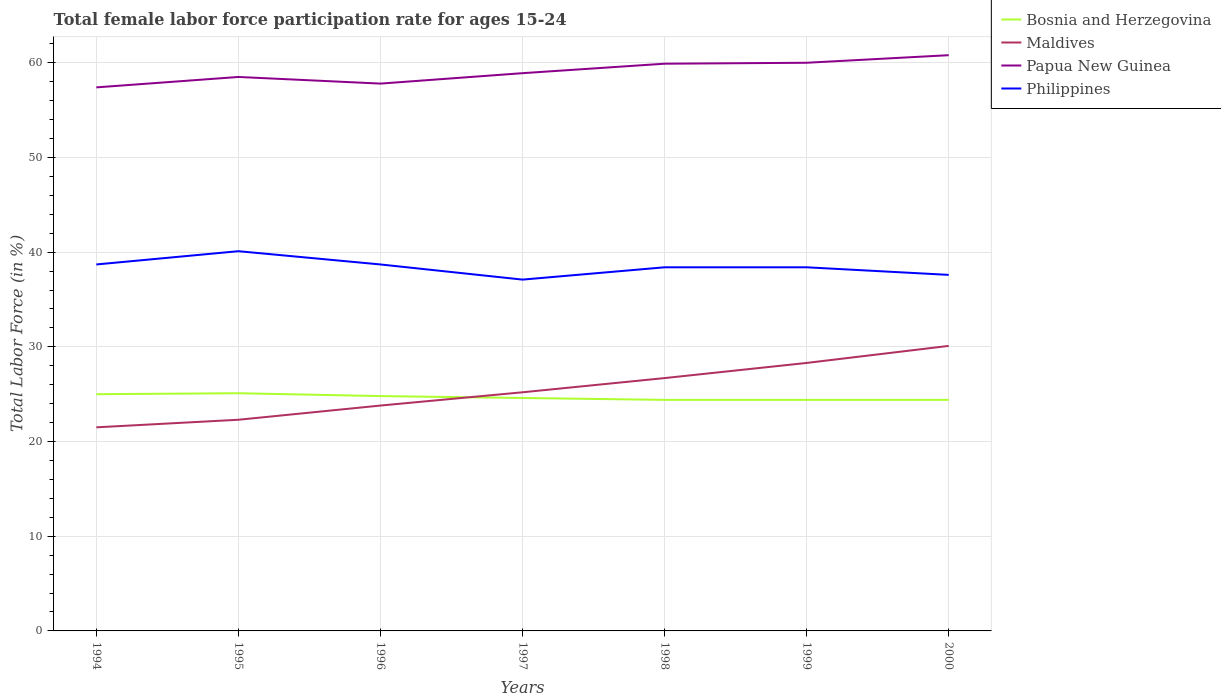Does the line corresponding to Maldives intersect with the line corresponding to Philippines?
Your answer should be very brief. No. Is the number of lines equal to the number of legend labels?
Give a very brief answer. Yes. What is the total female labor force participation rate in Philippines in the graph?
Provide a short and direct response. -1.4. What is the difference between the highest and the second highest female labor force participation rate in Bosnia and Herzegovina?
Offer a terse response. 0.7. What is the difference between the highest and the lowest female labor force participation rate in Philippines?
Provide a short and direct response. 3. Does the graph contain any zero values?
Offer a terse response. No. Where does the legend appear in the graph?
Ensure brevity in your answer.  Top right. How many legend labels are there?
Provide a succinct answer. 4. How are the legend labels stacked?
Your answer should be compact. Vertical. What is the title of the graph?
Your answer should be compact. Total female labor force participation rate for ages 15-24. Does "Costa Rica" appear as one of the legend labels in the graph?
Give a very brief answer. No. What is the Total Labor Force (in %) in Bosnia and Herzegovina in 1994?
Keep it short and to the point. 25. What is the Total Labor Force (in %) of Maldives in 1994?
Your answer should be compact. 21.5. What is the Total Labor Force (in %) of Papua New Guinea in 1994?
Your answer should be very brief. 57.4. What is the Total Labor Force (in %) of Philippines in 1994?
Ensure brevity in your answer.  38.7. What is the Total Labor Force (in %) in Bosnia and Herzegovina in 1995?
Make the answer very short. 25.1. What is the Total Labor Force (in %) of Maldives in 1995?
Your answer should be compact. 22.3. What is the Total Labor Force (in %) in Papua New Guinea in 1995?
Keep it short and to the point. 58.5. What is the Total Labor Force (in %) of Philippines in 1995?
Offer a terse response. 40.1. What is the Total Labor Force (in %) in Bosnia and Herzegovina in 1996?
Your answer should be very brief. 24.8. What is the Total Labor Force (in %) of Maldives in 1996?
Give a very brief answer. 23.8. What is the Total Labor Force (in %) in Papua New Guinea in 1996?
Make the answer very short. 57.8. What is the Total Labor Force (in %) in Philippines in 1996?
Your answer should be very brief. 38.7. What is the Total Labor Force (in %) of Bosnia and Herzegovina in 1997?
Ensure brevity in your answer.  24.6. What is the Total Labor Force (in %) of Maldives in 1997?
Your response must be concise. 25.2. What is the Total Labor Force (in %) in Papua New Guinea in 1997?
Your answer should be very brief. 58.9. What is the Total Labor Force (in %) in Philippines in 1997?
Offer a terse response. 37.1. What is the Total Labor Force (in %) in Bosnia and Herzegovina in 1998?
Provide a short and direct response. 24.4. What is the Total Labor Force (in %) of Maldives in 1998?
Give a very brief answer. 26.7. What is the Total Labor Force (in %) in Papua New Guinea in 1998?
Provide a short and direct response. 59.9. What is the Total Labor Force (in %) of Philippines in 1998?
Ensure brevity in your answer.  38.4. What is the Total Labor Force (in %) in Bosnia and Herzegovina in 1999?
Ensure brevity in your answer.  24.4. What is the Total Labor Force (in %) in Maldives in 1999?
Offer a terse response. 28.3. What is the Total Labor Force (in %) of Philippines in 1999?
Offer a very short reply. 38.4. What is the Total Labor Force (in %) in Bosnia and Herzegovina in 2000?
Your response must be concise. 24.4. What is the Total Labor Force (in %) in Maldives in 2000?
Provide a short and direct response. 30.1. What is the Total Labor Force (in %) of Papua New Guinea in 2000?
Provide a short and direct response. 60.8. What is the Total Labor Force (in %) of Philippines in 2000?
Your answer should be very brief. 37.6. Across all years, what is the maximum Total Labor Force (in %) of Bosnia and Herzegovina?
Provide a succinct answer. 25.1. Across all years, what is the maximum Total Labor Force (in %) in Maldives?
Keep it short and to the point. 30.1. Across all years, what is the maximum Total Labor Force (in %) of Papua New Guinea?
Make the answer very short. 60.8. Across all years, what is the maximum Total Labor Force (in %) of Philippines?
Make the answer very short. 40.1. Across all years, what is the minimum Total Labor Force (in %) in Bosnia and Herzegovina?
Provide a short and direct response. 24.4. Across all years, what is the minimum Total Labor Force (in %) in Maldives?
Offer a very short reply. 21.5. Across all years, what is the minimum Total Labor Force (in %) of Papua New Guinea?
Offer a terse response. 57.4. Across all years, what is the minimum Total Labor Force (in %) in Philippines?
Ensure brevity in your answer.  37.1. What is the total Total Labor Force (in %) in Bosnia and Herzegovina in the graph?
Offer a terse response. 172.7. What is the total Total Labor Force (in %) in Maldives in the graph?
Your answer should be compact. 177.9. What is the total Total Labor Force (in %) of Papua New Guinea in the graph?
Provide a short and direct response. 413.3. What is the total Total Labor Force (in %) of Philippines in the graph?
Your answer should be very brief. 269. What is the difference between the Total Labor Force (in %) in Maldives in 1994 and that in 1995?
Keep it short and to the point. -0.8. What is the difference between the Total Labor Force (in %) in Papua New Guinea in 1994 and that in 1995?
Give a very brief answer. -1.1. What is the difference between the Total Labor Force (in %) of Philippines in 1994 and that in 1995?
Provide a short and direct response. -1.4. What is the difference between the Total Labor Force (in %) of Papua New Guinea in 1994 and that in 1996?
Make the answer very short. -0.4. What is the difference between the Total Labor Force (in %) of Philippines in 1994 and that in 1997?
Your response must be concise. 1.6. What is the difference between the Total Labor Force (in %) in Bosnia and Herzegovina in 1994 and that in 1998?
Provide a succinct answer. 0.6. What is the difference between the Total Labor Force (in %) of Papua New Guinea in 1994 and that in 1998?
Keep it short and to the point. -2.5. What is the difference between the Total Labor Force (in %) of Maldives in 1994 and that in 1999?
Make the answer very short. -6.8. What is the difference between the Total Labor Force (in %) of Papua New Guinea in 1994 and that in 1999?
Offer a terse response. -2.6. What is the difference between the Total Labor Force (in %) of Philippines in 1994 and that in 1999?
Keep it short and to the point. 0.3. What is the difference between the Total Labor Force (in %) in Bosnia and Herzegovina in 1994 and that in 2000?
Your response must be concise. 0.6. What is the difference between the Total Labor Force (in %) of Maldives in 1994 and that in 2000?
Make the answer very short. -8.6. What is the difference between the Total Labor Force (in %) of Bosnia and Herzegovina in 1995 and that in 1996?
Keep it short and to the point. 0.3. What is the difference between the Total Labor Force (in %) in Philippines in 1995 and that in 1996?
Offer a very short reply. 1.4. What is the difference between the Total Labor Force (in %) in Bosnia and Herzegovina in 1995 and that in 1998?
Your response must be concise. 0.7. What is the difference between the Total Labor Force (in %) in Papua New Guinea in 1995 and that in 1998?
Give a very brief answer. -1.4. What is the difference between the Total Labor Force (in %) in Philippines in 1995 and that in 1998?
Your response must be concise. 1.7. What is the difference between the Total Labor Force (in %) of Bosnia and Herzegovina in 1995 and that in 1999?
Ensure brevity in your answer.  0.7. What is the difference between the Total Labor Force (in %) in Papua New Guinea in 1995 and that in 1999?
Provide a short and direct response. -1.5. What is the difference between the Total Labor Force (in %) in Philippines in 1995 and that in 1999?
Offer a very short reply. 1.7. What is the difference between the Total Labor Force (in %) of Bosnia and Herzegovina in 1995 and that in 2000?
Your response must be concise. 0.7. What is the difference between the Total Labor Force (in %) of Maldives in 1995 and that in 2000?
Your response must be concise. -7.8. What is the difference between the Total Labor Force (in %) of Papua New Guinea in 1995 and that in 2000?
Provide a succinct answer. -2.3. What is the difference between the Total Labor Force (in %) in Philippines in 1995 and that in 2000?
Ensure brevity in your answer.  2.5. What is the difference between the Total Labor Force (in %) in Bosnia and Herzegovina in 1996 and that in 1997?
Provide a succinct answer. 0.2. What is the difference between the Total Labor Force (in %) in Bosnia and Herzegovina in 1996 and that in 1999?
Your answer should be very brief. 0.4. What is the difference between the Total Labor Force (in %) in Maldives in 1996 and that in 1999?
Give a very brief answer. -4.5. What is the difference between the Total Labor Force (in %) in Philippines in 1996 and that in 1999?
Your answer should be compact. 0.3. What is the difference between the Total Labor Force (in %) of Bosnia and Herzegovina in 1996 and that in 2000?
Your answer should be compact. 0.4. What is the difference between the Total Labor Force (in %) in Philippines in 1996 and that in 2000?
Your answer should be compact. 1.1. What is the difference between the Total Labor Force (in %) in Bosnia and Herzegovina in 1997 and that in 1998?
Your answer should be very brief. 0.2. What is the difference between the Total Labor Force (in %) in Papua New Guinea in 1997 and that in 1998?
Provide a succinct answer. -1. What is the difference between the Total Labor Force (in %) of Philippines in 1997 and that in 1998?
Ensure brevity in your answer.  -1.3. What is the difference between the Total Labor Force (in %) in Bosnia and Herzegovina in 1997 and that in 1999?
Make the answer very short. 0.2. What is the difference between the Total Labor Force (in %) of Papua New Guinea in 1997 and that in 1999?
Offer a very short reply. -1.1. What is the difference between the Total Labor Force (in %) in Bosnia and Herzegovina in 1997 and that in 2000?
Offer a terse response. 0.2. What is the difference between the Total Labor Force (in %) in Philippines in 1997 and that in 2000?
Provide a short and direct response. -0.5. What is the difference between the Total Labor Force (in %) in Bosnia and Herzegovina in 1998 and that in 1999?
Give a very brief answer. 0. What is the difference between the Total Labor Force (in %) of Maldives in 1998 and that in 1999?
Keep it short and to the point. -1.6. What is the difference between the Total Labor Force (in %) in Philippines in 1998 and that in 1999?
Offer a very short reply. 0. What is the difference between the Total Labor Force (in %) of Bosnia and Herzegovina in 1999 and that in 2000?
Make the answer very short. 0. What is the difference between the Total Labor Force (in %) of Maldives in 1999 and that in 2000?
Give a very brief answer. -1.8. What is the difference between the Total Labor Force (in %) in Philippines in 1999 and that in 2000?
Your answer should be very brief. 0.8. What is the difference between the Total Labor Force (in %) of Bosnia and Herzegovina in 1994 and the Total Labor Force (in %) of Papua New Guinea in 1995?
Ensure brevity in your answer.  -33.5. What is the difference between the Total Labor Force (in %) in Bosnia and Herzegovina in 1994 and the Total Labor Force (in %) in Philippines in 1995?
Make the answer very short. -15.1. What is the difference between the Total Labor Force (in %) of Maldives in 1994 and the Total Labor Force (in %) of Papua New Guinea in 1995?
Your response must be concise. -37. What is the difference between the Total Labor Force (in %) of Maldives in 1994 and the Total Labor Force (in %) of Philippines in 1995?
Provide a succinct answer. -18.6. What is the difference between the Total Labor Force (in %) in Bosnia and Herzegovina in 1994 and the Total Labor Force (in %) in Maldives in 1996?
Your answer should be compact. 1.2. What is the difference between the Total Labor Force (in %) of Bosnia and Herzegovina in 1994 and the Total Labor Force (in %) of Papua New Guinea in 1996?
Ensure brevity in your answer.  -32.8. What is the difference between the Total Labor Force (in %) of Bosnia and Herzegovina in 1994 and the Total Labor Force (in %) of Philippines in 1996?
Make the answer very short. -13.7. What is the difference between the Total Labor Force (in %) in Maldives in 1994 and the Total Labor Force (in %) in Papua New Guinea in 1996?
Your answer should be compact. -36.3. What is the difference between the Total Labor Force (in %) of Maldives in 1994 and the Total Labor Force (in %) of Philippines in 1996?
Your response must be concise. -17.2. What is the difference between the Total Labor Force (in %) of Bosnia and Herzegovina in 1994 and the Total Labor Force (in %) of Maldives in 1997?
Keep it short and to the point. -0.2. What is the difference between the Total Labor Force (in %) of Bosnia and Herzegovina in 1994 and the Total Labor Force (in %) of Papua New Guinea in 1997?
Provide a short and direct response. -33.9. What is the difference between the Total Labor Force (in %) in Maldives in 1994 and the Total Labor Force (in %) in Papua New Guinea in 1997?
Provide a succinct answer. -37.4. What is the difference between the Total Labor Force (in %) in Maldives in 1994 and the Total Labor Force (in %) in Philippines in 1997?
Provide a succinct answer. -15.6. What is the difference between the Total Labor Force (in %) of Papua New Guinea in 1994 and the Total Labor Force (in %) of Philippines in 1997?
Ensure brevity in your answer.  20.3. What is the difference between the Total Labor Force (in %) in Bosnia and Herzegovina in 1994 and the Total Labor Force (in %) in Papua New Guinea in 1998?
Offer a very short reply. -34.9. What is the difference between the Total Labor Force (in %) in Bosnia and Herzegovina in 1994 and the Total Labor Force (in %) in Philippines in 1998?
Your response must be concise. -13.4. What is the difference between the Total Labor Force (in %) in Maldives in 1994 and the Total Labor Force (in %) in Papua New Guinea in 1998?
Your answer should be compact. -38.4. What is the difference between the Total Labor Force (in %) in Maldives in 1994 and the Total Labor Force (in %) in Philippines in 1998?
Offer a very short reply. -16.9. What is the difference between the Total Labor Force (in %) in Papua New Guinea in 1994 and the Total Labor Force (in %) in Philippines in 1998?
Your response must be concise. 19. What is the difference between the Total Labor Force (in %) in Bosnia and Herzegovina in 1994 and the Total Labor Force (in %) in Maldives in 1999?
Ensure brevity in your answer.  -3.3. What is the difference between the Total Labor Force (in %) in Bosnia and Herzegovina in 1994 and the Total Labor Force (in %) in Papua New Guinea in 1999?
Keep it short and to the point. -35. What is the difference between the Total Labor Force (in %) in Bosnia and Herzegovina in 1994 and the Total Labor Force (in %) in Philippines in 1999?
Keep it short and to the point. -13.4. What is the difference between the Total Labor Force (in %) in Maldives in 1994 and the Total Labor Force (in %) in Papua New Guinea in 1999?
Ensure brevity in your answer.  -38.5. What is the difference between the Total Labor Force (in %) in Maldives in 1994 and the Total Labor Force (in %) in Philippines in 1999?
Ensure brevity in your answer.  -16.9. What is the difference between the Total Labor Force (in %) in Bosnia and Herzegovina in 1994 and the Total Labor Force (in %) in Papua New Guinea in 2000?
Give a very brief answer. -35.8. What is the difference between the Total Labor Force (in %) of Maldives in 1994 and the Total Labor Force (in %) of Papua New Guinea in 2000?
Offer a terse response. -39.3. What is the difference between the Total Labor Force (in %) in Maldives in 1994 and the Total Labor Force (in %) in Philippines in 2000?
Offer a very short reply. -16.1. What is the difference between the Total Labor Force (in %) of Papua New Guinea in 1994 and the Total Labor Force (in %) of Philippines in 2000?
Provide a short and direct response. 19.8. What is the difference between the Total Labor Force (in %) of Bosnia and Herzegovina in 1995 and the Total Labor Force (in %) of Papua New Guinea in 1996?
Your answer should be very brief. -32.7. What is the difference between the Total Labor Force (in %) in Bosnia and Herzegovina in 1995 and the Total Labor Force (in %) in Philippines in 1996?
Your response must be concise. -13.6. What is the difference between the Total Labor Force (in %) in Maldives in 1995 and the Total Labor Force (in %) in Papua New Guinea in 1996?
Your response must be concise. -35.5. What is the difference between the Total Labor Force (in %) of Maldives in 1995 and the Total Labor Force (in %) of Philippines in 1996?
Provide a succinct answer. -16.4. What is the difference between the Total Labor Force (in %) in Papua New Guinea in 1995 and the Total Labor Force (in %) in Philippines in 1996?
Offer a terse response. 19.8. What is the difference between the Total Labor Force (in %) in Bosnia and Herzegovina in 1995 and the Total Labor Force (in %) in Papua New Guinea in 1997?
Give a very brief answer. -33.8. What is the difference between the Total Labor Force (in %) in Bosnia and Herzegovina in 1995 and the Total Labor Force (in %) in Philippines in 1997?
Provide a succinct answer. -12. What is the difference between the Total Labor Force (in %) of Maldives in 1995 and the Total Labor Force (in %) of Papua New Guinea in 1997?
Give a very brief answer. -36.6. What is the difference between the Total Labor Force (in %) of Maldives in 1995 and the Total Labor Force (in %) of Philippines in 1997?
Give a very brief answer. -14.8. What is the difference between the Total Labor Force (in %) in Papua New Guinea in 1995 and the Total Labor Force (in %) in Philippines in 1997?
Your answer should be compact. 21.4. What is the difference between the Total Labor Force (in %) of Bosnia and Herzegovina in 1995 and the Total Labor Force (in %) of Maldives in 1998?
Offer a very short reply. -1.6. What is the difference between the Total Labor Force (in %) in Bosnia and Herzegovina in 1995 and the Total Labor Force (in %) in Papua New Guinea in 1998?
Offer a very short reply. -34.8. What is the difference between the Total Labor Force (in %) of Maldives in 1995 and the Total Labor Force (in %) of Papua New Guinea in 1998?
Ensure brevity in your answer.  -37.6. What is the difference between the Total Labor Force (in %) of Maldives in 1995 and the Total Labor Force (in %) of Philippines in 1998?
Your response must be concise. -16.1. What is the difference between the Total Labor Force (in %) in Papua New Guinea in 1995 and the Total Labor Force (in %) in Philippines in 1998?
Offer a very short reply. 20.1. What is the difference between the Total Labor Force (in %) in Bosnia and Herzegovina in 1995 and the Total Labor Force (in %) in Maldives in 1999?
Your response must be concise. -3.2. What is the difference between the Total Labor Force (in %) of Bosnia and Herzegovina in 1995 and the Total Labor Force (in %) of Papua New Guinea in 1999?
Your response must be concise. -34.9. What is the difference between the Total Labor Force (in %) in Maldives in 1995 and the Total Labor Force (in %) in Papua New Guinea in 1999?
Ensure brevity in your answer.  -37.7. What is the difference between the Total Labor Force (in %) of Maldives in 1995 and the Total Labor Force (in %) of Philippines in 1999?
Offer a terse response. -16.1. What is the difference between the Total Labor Force (in %) in Papua New Guinea in 1995 and the Total Labor Force (in %) in Philippines in 1999?
Ensure brevity in your answer.  20.1. What is the difference between the Total Labor Force (in %) of Bosnia and Herzegovina in 1995 and the Total Labor Force (in %) of Papua New Guinea in 2000?
Give a very brief answer. -35.7. What is the difference between the Total Labor Force (in %) in Maldives in 1995 and the Total Labor Force (in %) in Papua New Guinea in 2000?
Your answer should be compact. -38.5. What is the difference between the Total Labor Force (in %) in Maldives in 1995 and the Total Labor Force (in %) in Philippines in 2000?
Offer a terse response. -15.3. What is the difference between the Total Labor Force (in %) in Papua New Guinea in 1995 and the Total Labor Force (in %) in Philippines in 2000?
Make the answer very short. 20.9. What is the difference between the Total Labor Force (in %) of Bosnia and Herzegovina in 1996 and the Total Labor Force (in %) of Maldives in 1997?
Provide a short and direct response. -0.4. What is the difference between the Total Labor Force (in %) in Bosnia and Herzegovina in 1996 and the Total Labor Force (in %) in Papua New Guinea in 1997?
Offer a very short reply. -34.1. What is the difference between the Total Labor Force (in %) of Bosnia and Herzegovina in 1996 and the Total Labor Force (in %) of Philippines in 1997?
Offer a terse response. -12.3. What is the difference between the Total Labor Force (in %) of Maldives in 1996 and the Total Labor Force (in %) of Papua New Guinea in 1997?
Your answer should be compact. -35.1. What is the difference between the Total Labor Force (in %) in Papua New Guinea in 1996 and the Total Labor Force (in %) in Philippines in 1997?
Provide a short and direct response. 20.7. What is the difference between the Total Labor Force (in %) of Bosnia and Herzegovina in 1996 and the Total Labor Force (in %) of Maldives in 1998?
Provide a short and direct response. -1.9. What is the difference between the Total Labor Force (in %) of Bosnia and Herzegovina in 1996 and the Total Labor Force (in %) of Papua New Guinea in 1998?
Give a very brief answer. -35.1. What is the difference between the Total Labor Force (in %) in Bosnia and Herzegovina in 1996 and the Total Labor Force (in %) in Philippines in 1998?
Your response must be concise. -13.6. What is the difference between the Total Labor Force (in %) of Maldives in 1996 and the Total Labor Force (in %) of Papua New Guinea in 1998?
Your answer should be very brief. -36.1. What is the difference between the Total Labor Force (in %) of Maldives in 1996 and the Total Labor Force (in %) of Philippines in 1998?
Offer a very short reply. -14.6. What is the difference between the Total Labor Force (in %) of Bosnia and Herzegovina in 1996 and the Total Labor Force (in %) of Papua New Guinea in 1999?
Ensure brevity in your answer.  -35.2. What is the difference between the Total Labor Force (in %) of Maldives in 1996 and the Total Labor Force (in %) of Papua New Guinea in 1999?
Give a very brief answer. -36.2. What is the difference between the Total Labor Force (in %) in Maldives in 1996 and the Total Labor Force (in %) in Philippines in 1999?
Ensure brevity in your answer.  -14.6. What is the difference between the Total Labor Force (in %) of Bosnia and Herzegovina in 1996 and the Total Labor Force (in %) of Maldives in 2000?
Your response must be concise. -5.3. What is the difference between the Total Labor Force (in %) of Bosnia and Herzegovina in 1996 and the Total Labor Force (in %) of Papua New Guinea in 2000?
Ensure brevity in your answer.  -36. What is the difference between the Total Labor Force (in %) of Maldives in 1996 and the Total Labor Force (in %) of Papua New Guinea in 2000?
Keep it short and to the point. -37. What is the difference between the Total Labor Force (in %) of Papua New Guinea in 1996 and the Total Labor Force (in %) of Philippines in 2000?
Your answer should be very brief. 20.2. What is the difference between the Total Labor Force (in %) in Bosnia and Herzegovina in 1997 and the Total Labor Force (in %) in Maldives in 1998?
Offer a very short reply. -2.1. What is the difference between the Total Labor Force (in %) of Bosnia and Herzegovina in 1997 and the Total Labor Force (in %) of Papua New Guinea in 1998?
Make the answer very short. -35.3. What is the difference between the Total Labor Force (in %) in Maldives in 1997 and the Total Labor Force (in %) in Papua New Guinea in 1998?
Ensure brevity in your answer.  -34.7. What is the difference between the Total Labor Force (in %) in Papua New Guinea in 1997 and the Total Labor Force (in %) in Philippines in 1998?
Your response must be concise. 20.5. What is the difference between the Total Labor Force (in %) in Bosnia and Herzegovina in 1997 and the Total Labor Force (in %) in Papua New Guinea in 1999?
Give a very brief answer. -35.4. What is the difference between the Total Labor Force (in %) in Bosnia and Herzegovina in 1997 and the Total Labor Force (in %) in Philippines in 1999?
Offer a very short reply. -13.8. What is the difference between the Total Labor Force (in %) in Maldives in 1997 and the Total Labor Force (in %) in Papua New Guinea in 1999?
Your answer should be very brief. -34.8. What is the difference between the Total Labor Force (in %) of Papua New Guinea in 1997 and the Total Labor Force (in %) of Philippines in 1999?
Your answer should be compact. 20.5. What is the difference between the Total Labor Force (in %) in Bosnia and Herzegovina in 1997 and the Total Labor Force (in %) in Papua New Guinea in 2000?
Keep it short and to the point. -36.2. What is the difference between the Total Labor Force (in %) of Bosnia and Herzegovina in 1997 and the Total Labor Force (in %) of Philippines in 2000?
Make the answer very short. -13. What is the difference between the Total Labor Force (in %) in Maldives in 1997 and the Total Labor Force (in %) in Papua New Guinea in 2000?
Offer a terse response. -35.6. What is the difference between the Total Labor Force (in %) of Papua New Guinea in 1997 and the Total Labor Force (in %) of Philippines in 2000?
Offer a very short reply. 21.3. What is the difference between the Total Labor Force (in %) in Bosnia and Herzegovina in 1998 and the Total Labor Force (in %) in Papua New Guinea in 1999?
Provide a succinct answer. -35.6. What is the difference between the Total Labor Force (in %) of Bosnia and Herzegovina in 1998 and the Total Labor Force (in %) of Philippines in 1999?
Ensure brevity in your answer.  -14. What is the difference between the Total Labor Force (in %) of Maldives in 1998 and the Total Labor Force (in %) of Papua New Guinea in 1999?
Keep it short and to the point. -33.3. What is the difference between the Total Labor Force (in %) of Maldives in 1998 and the Total Labor Force (in %) of Philippines in 1999?
Make the answer very short. -11.7. What is the difference between the Total Labor Force (in %) in Papua New Guinea in 1998 and the Total Labor Force (in %) in Philippines in 1999?
Make the answer very short. 21.5. What is the difference between the Total Labor Force (in %) of Bosnia and Herzegovina in 1998 and the Total Labor Force (in %) of Papua New Guinea in 2000?
Your answer should be compact. -36.4. What is the difference between the Total Labor Force (in %) of Bosnia and Herzegovina in 1998 and the Total Labor Force (in %) of Philippines in 2000?
Keep it short and to the point. -13.2. What is the difference between the Total Labor Force (in %) in Maldives in 1998 and the Total Labor Force (in %) in Papua New Guinea in 2000?
Offer a very short reply. -34.1. What is the difference between the Total Labor Force (in %) in Papua New Guinea in 1998 and the Total Labor Force (in %) in Philippines in 2000?
Your answer should be compact. 22.3. What is the difference between the Total Labor Force (in %) of Bosnia and Herzegovina in 1999 and the Total Labor Force (in %) of Papua New Guinea in 2000?
Provide a short and direct response. -36.4. What is the difference between the Total Labor Force (in %) of Bosnia and Herzegovina in 1999 and the Total Labor Force (in %) of Philippines in 2000?
Make the answer very short. -13.2. What is the difference between the Total Labor Force (in %) in Maldives in 1999 and the Total Labor Force (in %) in Papua New Guinea in 2000?
Your answer should be very brief. -32.5. What is the difference between the Total Labor Force (in %) of Papua New Guinea in 1999 and the Total Labor Force (in %) of Philippines in 2000?
Your answer should be compact. 22.4. What is the average Total Labor Force (in %) in Bosnia and Herzegovina per year?
Give a very brief answer. 24.67. What is the average Total Labor Force (in %) of Maldives per year?
Your response must be concise. 25.41. What is the average Total Labor Force (in %) of Papua New Guinea per year?
Keep it short and to the point. 59.04. What is the average Total Labor Force (in %) in Philippines per year?
Give a very brief answer. 38.43. In the year 1994, what is the difference between the Total Labor Force (in %) of Bosnia and Herzegovina and Total Labor Force (in %) of Papua New Guinea?
Make the answer very short. -32.4. In the year 1994, what is the difference between the Total Labor Force (in %) in Bosnia and Herzegovina and Total Labor Force (in %) in Philippines?
Your response must be concise. -13.7. In the year 1994, what is the difference between the Total Labor Force (in %) of Maldives and Total Labor Force (in %) of Papua New Guinea?
Give a very brief answer. -35.9. In the year 1994, what is the difference between the Total Labor Force (in %) in Maldives and Total Labor Force (in %) in Philippines?
Offer a very short reply. -17.2. In the year 1995, what is the difference between the Total Labor Force (in %) of Bosnia and Herzegovina and Total Labor Force (in %) of Papua New Guinea?
Ensure brevity in your answer.  -33.4. In the year 1995, what is the difference between the Total Labor Force (in %) of Bosnia and Herzegovina and Total Labor Force (in %) of Philippines?
Provide a short and direct response. -15. In the year 1995, what is the difference between the Total Labor Force (in %) of Maldives and Total Labor Force (in %) of Papua New Guinea?
Your answer should be very brief. -36.2. In the year 1995, what is the difference between the Total Labor Force (in %) in Maldives and Total Labor Force (in %) in Philippines?
Keep it short and to the point. -17.8. In the year 1995, what is the difference between the Total Labor Force (in %) in Papua New Guinea and Total Labor Force (in %) in Philippines?
Offer a very short reply. 18.4. In the year 1996, what is the difference between the Total Labor Force (in %) of Bosnia and Herzegovina and Total Labor Force (in %) of Maldives?
Keep it short and to the point. 1. In the year 1996, what is the difference between the Total Labor Force (in %) of Bosnia and Herzegovina and Total Labor Force (in %) of Papua New Guinea?
Your response must be concise. -33. In the year 1996, what is the difference between the Total Labor Force (in %) in Maldives and Total Labor Force (in %) in Papua New Guinea?
Provide a short and direct response. -34. In the year 1996, what is the difference between the Total Labor Force (in %) of Maldives and Total Labor Force (in %) of Philippines?
Provide a short and direct response. -14.9. In the year 1996, what is the difference between the Total Labor Force (in %) in Papua New Guinea and Total Labor Force (in %) in Philippines?
Ensure brevity in your answer.  19.1. In the year 1997, what is the difference between the Total Labor Force (in %) in Bosnia and Herzegovina and Total Labor Force (in %) in Maldives?
Provide a succinct answer. -0.6. In the year 1997, what is the difference between the Total Labor Force (in %) in Bosnia and Herzegovina and Total Labor Force (in %) in Papua New Guinea?
Give a very brief answer. -34.3. In the year 1997, what is the difference between the Total Labor Force (in %) in Bosnia and Herzegovina and Total Labor Force (in %) in Philippines?
Give a very brief answer. -12.5. In the year 1997, what is the difference between the Total Labor Force (in %) of Maldives and Total Labor Force (in %) of Papua New Guinea?
Give a very brief answer. -33.7. In the year 1997, what is the difference between the Total Labor Force (in %) in Papua New Guinea and Total Labor Force (in %) in Philippines?
Offer a terse response. 21.8. In the year 1998, what is the difference between the Total Labor Force (in %) of Bosnia and Herzegovina and Total Labor Force (in %) of Maldives?
Your answer should be compact. -2.3. In the year 1998, what is the difference between the Total Labor Force (in %) of Bosnia and Herzegovina and Total Labor Force (in %) of Papua New Guinea?
Ensure brevity in your answer.  -35.5. In the year 1998, what is the difference between the Total Labor Force (in %) of Bosnia and Herzegovina and Total Labor Force (in %) of Philippines?
Provide a succinct answer. -14. In the year 1998, what is the difference between the Total Labor Force (in %) of Maldives and Total Labor Force (in %) of Papua New Guinea?
Your answer should be very brief. -33.2. In the year 1998, what is the difference between the Total Labor Force (in %) of Papua New Guinea and Total Labor Force (in %) of Philippines?
Provide a short and direct response. 21.5. In the year 1999, what is the difference between the Total Labor Force (in %) of Bosnia and Herzegovina and Total Labor Force (in %) of Maldives?
Ensure brevity in your answer.  -3.9. In the year 1999, what is the difference between the Total Labor Force (in %) in Bosnia and Herzegovina and Total Labor Force (in %) in Papua New Guinea?
Provide a succinct answer. -35.6. In the year 1999, what is the difference between the Total Labor Force (in %) in Bosnia and Herzegovina and Total Labor Force (in %) in Philippines?
Your answer should be very brief. -14. In the year 1999, what is the difference between the Total Labor Force (in %) in Maldives and Total Labor Force (in %) in Papua New Guinea?
Your response must be concise. -31.7. In the year 1999, what is the difference between the Total Labor Force (in %) of Papua New Guinea and Total Labor Force (in %) of Philippines?
Provide a short and direct response. 21.6. In the year 2000, what is the difference between the Total Labor Force (in %) of Bosnia and Herzegovina and Total Labor Force (in %) of Maldives?
Ensure brevity in your answer.  -5.7. In the year 2000, what is the difference between the Total Labor Force (in %) in Bosnia and Herzegovina and Total Labor Force (in %) in Papua New Guinea?
Make the answer very short. -36.4. In the year 2000, what is the difference between the Total Labor Force (in %) in Maldives and Total Labor Force (in %) in Papua New Guinea?
Your response must be concise. -30.7. In the year 2000, what is the difference between the Total Labor Force (in %) of Papua New Guinea and Total Labor Force (in %) of Philippines?
Offer a very short reply. 23.2. What is the ratio of the Total Labor Force (in %) in Maldives in 1994 to that in 1995?
Provide a short and direct response. 0.96. What is the ratio of the Total Labor Force (in %) in Papua New Guinea in 1994 to that in 1995?
Keep it short and to the point. 0.98. What is the ratio of the Total Labor Force (in %) in Philippines in 1994 to that in 1995?
Your response must be concise. 0.97. What is the ratio of the Total Labor Force (in %) in Bosnia and Herzegovina in 1994 to that in 1996?
Keep it short and to the point. 1.01. What is the ratio of the Total Labor Force (in %) in Maldives in 1994 to that in 1996?
Offer a terse response. 0.9. What is the ratio of the Total Labor Force (in %) of Bosnia and Herzegovina in 1994 to that in 1997?
Provide a succinct answer. 1.02. What is the ratio of the Total Labor Force (in %) in Maldives in 1994 to that in 1997?
Ensure brevity in your answer.  0.85. What is the ratio of the Total Labor Force (in %) of Papua New Guinea in 1994 to that in 1997?
Offer a terse response. 0.97. What is the ratio of the Total Labor Force (in %) of Philippines in 1994 to that in 1997?
Make the answer very short. 1.04. What is the ratio of the Total Labor Force (in %) in Bosnia and Herzegovina in 1994 to that in 1998?
Provide a short and direct response. 1.02. What is the ratio of the Total Labor Force (in %) of Maldives in 1994 to that in 1998?
Ensure brevity in your answer.  0.81. What is the ratio of the Total Labor Force (in %) of Papua New Guinea in 1994 to that in 1998?
Provide a succinct answer. 0.96. What is the ratio of the Total Labor Force (in %) in Bosnia and Herzegovina in 1994 to that in 1999?
Provide a succinct answer. 1.02. What is the ratio of the Total Labor Force (in %) of Maldives in 1994 to that in 1999?
Ensure brevity in your answer.  0.76. What is the ratio of the Total Labor Force (in %) of Papua New Guinea in 1994 to that in 1999?
Your response must be concise. 0.96. What is the ratio of the Total Labor Force (in %) in Bosnia and Herzegovina in 1994 to that in 2000?
Provide a short and direct response. 1.02. What is the ratio of the Total Labor Force (in %) of Maldives in 1994 to that in 2000?
Provide a short and direct response. 0.71. What is the ratio of the Total Labor Force (in %) in Papua New Guinea in 1994 to that in 2000?
Provide a succinct answer. 0.94. What is the ratio of the Total Labor Force (in %) in Philippines in 1994 to that in 2000?
Keep it short and to the point. 1.03. What is the ratio of the Total Labor Force (in %) of Bosnia and Herzegovina in 1995 to that in 1996?
Your response must be concise. 1.01. What is the ratio of the Total Labor Force (in %) in Maldives in 1995 to that in 1996?
Your response must be concise. 0.94. What is the ratio of the Total Labor Force (in %) in Papua New Guinea in 1995 to that in 1996?
Make the answer very short. 1.01. What is the ratio of the Total Labor Force (in %) in Philippines in 1995 to that in 1996?
Your answer should be compact. 1.04. What is the ratio of the Total Labor Force (in %) in Bosnia and Herzegovina in 1995 to that in 1997?
Your answer should be compact. 1.02. What is the ratio of the Total Labor Force (in %) of Maldives in 1995 to that in 1997?
Your answer should be compact. 0.88. What is the ratio of the Total Labor Force (in %) of Papua New Guinea in 1995 to that in 1997?
Provide a succinct answer. 0.99. What is the ratio of the Total Labor Force (in %) of Philippines in 1995 to that in 1997?
Provide a succinct answer. 1.08. What is the ratio of the Total Labor Force (in %) in Bosnia and Herzegovina in 1995 to that in 1998?
Your response must be concise. 1.03. What is the ratio of the Total Labor Force (in %) of Maldives in 1995 to that in 1998?
Offer a terse response. 0.84. What is the ratio of the Total Labor Force (in %) in Papua New Guinea in 1995 to that in 1998?
Give a very brief answer. 0.98. What is the ratio of the Total Labor Force (in %) in Philippines in 1995 to that in 1998?
Your answer should be compact. 1.04. What is the ratio of the Total Labor Force (in %) of Bosnia and Herzegovina in 1995 to that in 1999?
Ensure brevity in your answer.  1.03. What is the ratio of the Total Labor Force (in %) of Maldives in 1995 to that in 1999?
Offer a terse response. 0.79. What is the ratio of the Total Labor Force (in %) in Philippines in 1995 to that in 1999?
Offer a terse response. 1.04. What is the ratio of the Total Labor Force (in %) of Bosnia and Herzegovina in 1995 to that in 2000?
Give a very brief answer. 1.03. What is the ratio of the Total Labor Force (in %) in Maldives in 1995 to that in 2000?
Provide a succinct answer. 0.74. What is the ratio of the Total Labor Force (in %) in Papua New Guinea in 1995 to that in 2000?
Your response must be concise. 0.96. What is the ratio of the Total Labor Force (in %) in Philippines in 1995 to that in 2000?
Make the answer very short. 1.07. What is the ratio of the Total Labor Force (in %) in Bosnia and Herzegovina in 1996 to that in 1997?
Keep it short and to the point. 1.01. What is the ratio of the Total Labor Force (in %) of Papua New Guinea in 1996 to that in 1997?
Your response must be concise. 0.98. What is the ratio of the Total Labor Force (in %) in Philippines in 1996 to that in 1997?
Your answer should be compact. 1.04. What is the ratio of the Total Labor Force (in %) in Bosnia and Herzegovina in 1996 to that in 1998?
Keep it short and to the point. 1.02. What is the ratio of the Total Labor Force (in %) of Maldives in 1996 to that in 1998?
Your answer should be very brief. 0.89. What is the ratio of the Total Labor Force (in %) in Papua New Guinea in 1996 to that in 1998?
Your response must be concise. 0.96. What is the ratio of the Total Labor Force (in %) in Bosnia and Herzegovina in 1996 to that in 1999?
Your answer should be compact. 1.02. What is the ratio of the Total Labor Force (in %) in Maldives in 1996 to that in 1999?
Your response must be concise. 0.84. What is the ratio of the Total Labor Force (in %) in Papua New Guinea in 1996 to that in 1999?
Your response must be concise. 0.96. What is the ratio of the Total Labor Force (in %) in Philippines in 1996 to that in 1999?
Provide a succinct answer. 1.01. What is the ratio of the Total Labor Force (in %) in Bosnia and Herzegovina in 1996 to that in 2000?
Provide a succinct answer. 1.02. What is the ratio of the Total Labor Force (in %) of Maldives in 1996 to that in 2000?
Your response must be concise. 0.79. What is the ratio of the Total Labor Force (in %) of Papua New Guinea in 1996 to that in 2000?
Your answer should be compact. 0.95. What is the ratio of the Total Labor Force (in %) in Philippines in 1996 to that in 2000?
Your response must be concise. 1.03. What is the ratio of the Total Labor Force (in %) in Bosnia and Herzegovina in 1997 to that in 1998?
Provide a succinct answer. 1.01. What is the ratio of the Total Labor Force (in %) in Maldives in 1997 to that in 1998?
Offer a very short reply. 0.94. What is the ratio of the Total Labor Force (in %) in Papua New Guinea in 1997 to that in 1998?
Ensure brevity in your answer.  0.98. What is the ratio of the Total Labor Force (in %) in Philippines in 1997 to that in 1998?
Your response must be concise. 0.97. What is the ratio of the Total Labor Force (in %) in Bosnia and Herzegovina in 1997 to that in 1999?
Keep it short and to the point. 1.01. What is the ratio of the Total Labor Force (in %) of Maldives in 1997 to that in 1999?
Provide a short and direct response. 0.89. What is the ratio of the Total Labor Force (in %) in Papua New Guinea in 1997 to that in 1999?
Offer a terse response. 0.98. What is the ratio of the Total Labor Force (in %) in Philippines in 1997 to that in 1999?
Provide a succinct answer. 0.97. What is the ratio of the Total Labor Force (in %) in Bosnia and Herzegovina in 1997 to that in 2000?
Keep it short and to the point. 1.01. What is the ratio of the Total Labor Force (in %) of Maldives in 1997 to that in 2000?
Make the answer very short. 0.84. What is the ratio of the Total Labor Force (in %) of Papua New Guinea in 1997 to that in 2000?
Offer a terse response. 0.97. What is the ratio of the Total Labor Force (in %) of Philippines in 1997 to that in 2000?
Your answer should be very brief. 0.99. What is the ratio of the Total Labor Force (in %) in Maldives in 1998 to that in 1999?
Keep it short and to the point. 0.94. What is the ratio of the Total Labor Force (in %) in Papua New Guinea in 1998 to that in 1999?
Your response must be concise. 1. What is the ratio of the Total Labor Force (in %) in Bosnia and Herzegovina in 1998 to that in 2000?
Provide a succinct answer. 1. What is the ratio of the Total Labor Force (in %) in Maldives in 1998 to that in 2000?
Provide a succinct answer. 0.89. What is the ratio of the Total Labor Force (in %) of Papua New Guinea in 1998 to that in 2000?
Make the answer very short. 0.99. What is the ratio of the Total Labor Force (in %) of Philippines in 1998 to that in 2000?
Give a very brief answer. 1.02. What is the ratio of the Total Labor Force (in %) of Bosnia and Herzegovina in 1999 to that in 2000?
Provide a short and direct response. 1. What is the ratio of the Total Labor Force (in %) of Maldives in 1999 to that in 2000?
Provide a short and direct response. 0.94. What is the ratio of the Total Labor Force (in %) of Papua New Guinea in 1999 to that in 2000?
Your answer should be compact. 0.99. What is the ratio of the Total Labor Force (in %) in Philippines in 1999 to that in 2000?
Your response must be concise. 1.02. What is the difference between the highest and the second highest Total Labor Force (in %) in Maldives?
Give a very brief answer. 1.8. What is the difference between the highest and the second highest Total Labor Force (in %) in Papua New Guinea?
Offer a terse response. 0.8. What is the difference between the highest and the second highest Total Labor Force (in %) of Philippines?
Provide a short and direct response. 1.4. What is the difference between the highest and the lowest Total Labor Force (in %) of Maldives?
Offer a very short reply. 8.6. What is the difference between the highest and the lowest Total Labor Force (in %) of Philippines?
Keep it short and to the point. 3. 